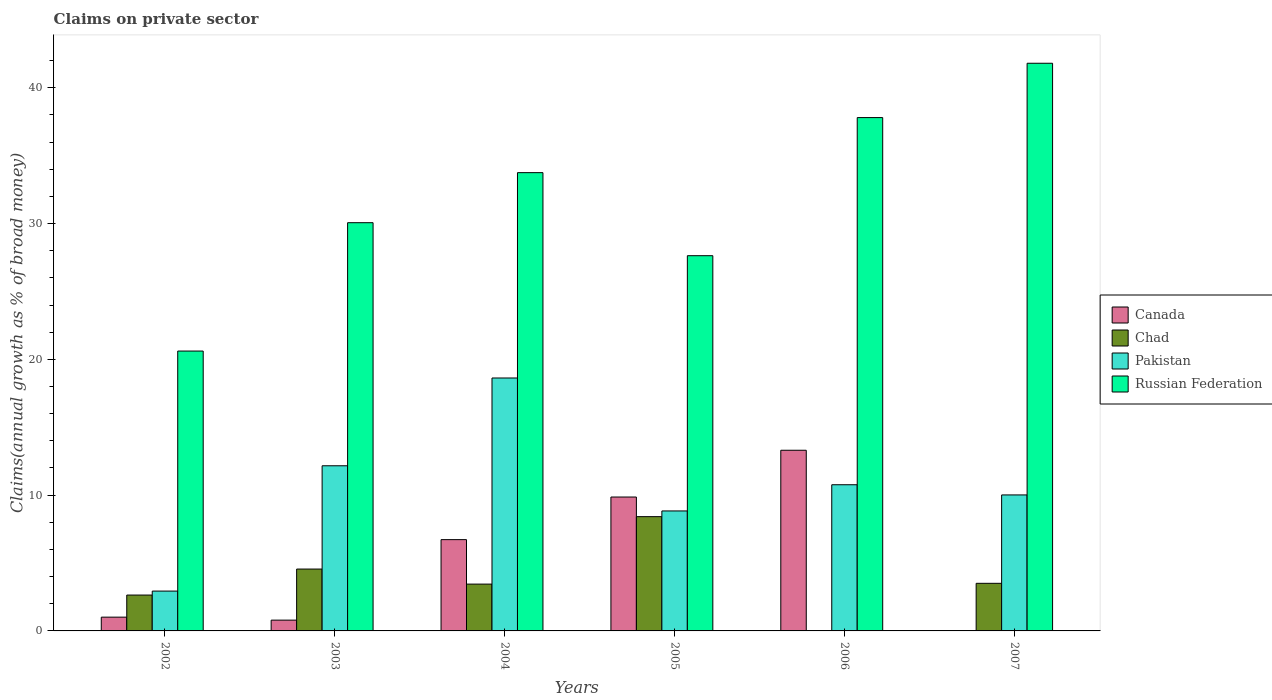Are the number of bars per tick equal to the number of legend labels?
Give a very brief answer. No. How many bars are there on the 4th tick from the right?
Ensure brevity in your answer.  4. In how many cases, is the number of bars for a given year not equal to the number of legend labels?
Your answer should be compact. 2. What is the percentage of broad money claimed on private sector in Chad in 2005?
Provide a short and direct response. 8.42. Across all years, what is the maximum percentage of broad money claimed on private sector in Pakistan?
Offer a very short reply. 18.63. What is the total percentage of broad money claimed on private sector in Canada in the graph?
Keep it short and to the point. 31.7. What is the difference between the percentage of broad money claimed on private sector in Pakistan in 2002 and that in 2007?
Give a very brief answer. -7.08. What is the difference between the percentage of broad money claimed on private sector in Canada in 2007 and the percentage of broad money claimed on private sector in Russian Federation in 2003?
Offer a very short reply. -30.06. What is the average percentage of broad money claimed on private sector in Russian Federation per year?
Provide a short and direct response. 31.94. In the year 2002, what is the difference between the percentage of broad money claimed on private sector in Canada and percentage of broad money claimed on private sector in Chad?
Ensure brevity in your answer.  -1.63. In how many years, is the percentage of broad money claimed on private sector in Pakistan greater than 6 %?
Offer a terse response. 5. What is the ratio of the percentage of broad money claimed on private sector in Chad in 2003 to that in 2007?
Your answer should be very brief. 1.3. Is the difference between the percentage of broad money claimed on private sector in Canada in 2004 and 2005 greater than the difference between the percentage of broad money claimed on private sector in Chad in 2004 and 2005?
Your answer should be very brief. Yes. What is the difference between the highest and the second highest percentage of broad money claimed on private sector in Pakistan?
Your response must be concise. 6.46. What is the difference between the highest and the lowest percentage of broad money claimed on private sector in Russian Federation?
Keep it short and to the point. 21.19. In how many years, is the percentage of broad money claimed on private sector in Chad greater than the average percentage of broad money claimed on private sector in Chad taken over all years?
Offer a terse response. 2. Is the sum of the percentage of broad money claimed on private sector in Chad in 2003 and 2004 greater than the maximum percentage of broad money claimed on private sector in Pakistan across all years?
Offer a terse response. No. What is the difference between two consecutive major ticks on the Y-axis?
Provide a succinct answer. 10. How are the legend labels stacked?
Your response must be concise. Vertical. What is the title of the graph?
Give a very brief answer. Claims on private sector. What is the label or title of the X-axis?
Your response must be concise. Years. What is the label or title of the Y-axis?
Provide a succinct answer. Claims(annual growth as % of broad money). What is the Claims(annual growth as % of broad money) of Canada in 2002?
Offer a very short reply. 1.01. What is the Claims(annual growth as % of broad money) in Chad in 2002?
Your answer should be compact. 2.64. What is the Claims(annual growth as % of broad money) in Pakistan in 2002?
Provide a short and direct response. 2.93. What is the Claims(annual growth as % of broad money) of Russian Federation in 2002?
Keep it short and to the point. 20.61. What is the Claims(annual growth as % of broad money) in Canada in 2003?
Provide a short and direct response. 0.79. What is the Claims(annual growth as % of broad money) in Chad in 2003?
Your response must be concise. 4.56. What is the Claims(annual growth as % of broad money) in Pakistan in 2003?
Your answer should be compact. 12.16. What is the Claims(annual growth as % of broad money) of Russian Federation in 2003?
Keep it short and to the point. 30.06. What is the Claims(annual growth as % of broad money) of Canada in 2004?
Ensure brevity in your answer.  6.72. What is the Claims(annual growth as % of broad money) of Chad in 2004?
Offer a very short reply. 3.45. What is the Claims(annual growth as % of broad money) in Pakistan in 2004?
Make the answer very short. 18.63. What is the Claims(annual growth as % of broad money) in Russian Federation in 2004?
Your response must be concise. 33.75. What is the Claims(annual growth as % of broad money) of Canada in 2005?
Your answer should be very brief. 9.86. What is the Claims(annual growth as % of broad money) of Chad in 2005?
Keep it short and to the point. 8.42. What is the Claims(annual growth as % of broad money) in Pakistan in 2005?
Give a very brief answer. 8.84. What is the Claims(annual growth as % of broad money) in Russian Federation in 2005?
Give a very brief answer. 27.63. What is the Claims(annual growth as % of broad money) in Canada in 2006?
Ensure brevity in your answer.  13.31. What is the Claims(annual growth as % of broad money) of Pakistan in 2006?
Provide a short and direct response. 10.76. What is the Claims(annual growth as % of broad money) of Russian Federation in 2006?
Offer a terse response. 37.8. What is the Claims(annual growth as % of broad money) of Canada in 2007?
Your answer should be compact. 0. What is the Claims(annual growth as % of broad money) in Chad in 2007?
Your response must be concise. 3.51. What is the Claims(annual growth as % of broad money) in Pakistan in 2007?
Offer a terse response. 10.01. What is the Claims(annual growth as % of broad money) in Russian Federation in 2007?
Offer a terse response. 41.8. Across all years, what is the maximum Claims(annual growth as % of broad money) in Canada?
Your answer should be very brief. 13.31. Across all years, what is the maximum Claims(annual growth as % of broad money) in Chad?
Your answer should be compact. 8.42. Across all years, what is the maximum Claims(annual growth as % of broad money) of Pakistan?
Make the answer very short. 18.63. Across all years, what is the maximum Claims(annual growth as % of broad money) in Russian Federation?
Ensure brevity in your answer.  41.8. Across all years, what is the minimum Claims(annual growth as % of broad money) of Chad?
Provide a succinct answer. 0. Across all years, what is the minimum Claims(annual growth as % of broad money) of Pakistan?
Your answer should be very brief. 2.93. Across all years, what is the minimum Claims(annual growth as % of broad money) in Russian Federation?
Give a very brief answer. 20.61. What is the total Claims(annual growth as % of broad money) in Canada in the graph?
Make the answer very short. 31.7. What is the total Claims(annual growth as % of broad money) of Chad in the graph?
Offer a terse response. 22.57. What is the total Claims(annual growth as % of broad money) of Pakistan in the graph?
Provide a short and direct response. 63.34. What is the total Claims(annual growth as % of broad money) in Russian Federation in the graph?
Provide a short and direct response. 191.66. What is the difference between the Claims(annual growth as % of broad money) of Canada in 2002 and that in 2003?
Ensure brevity in your answer.  0.22. What is the difference between the Claims(annual growth as % of broad money) of Chad in 2002 and that in 2003?
Your answer should be very brief. -1.91. What is the difference between the Claims(annual growth as % of broad money) of Pakistan in 2002 and that in 2003?
Keep it short and to the point. -9.23. What is the difference between the Claims(annual growth as % of broad money) in Russian Federation in 2002 and that in 2003?
Your answer should be very brief. -9.45. What is the difference between the Claims(annual growth as % of broad money) in Canada in 2002 and that in 2004?
Offer a very short reply. -5.71. What is the difference between the Claims(annual growth as % of broad money) in Chad in 2002 and that in 2004?
Your response must be concise. -0.81. What is the difference between the Claims(annual growth as % of broad money) of Pakistan in 2002 and that in 2004?
Your answer should be compact. -15.69. What is the difference between the Claims(annual growth as % of broad money) of Russian Federation in 2002 and that in 2004?
Offer a terse response. -13.14. What is the difference between the Claims(annual growth as % of broad money) in Canada in 2002 and that in 2005?
Keep it short and to the point. -8.85. What is the difference between the Claims(annual growth as % of broad money) of Chad in 2002 and that in 2005?
Ensure brevity in your answer.  -5.77. What is the difference between the Claims(annual growth as % of broad money) of Pakistan in 2002 and that in 2005?
Your answer should be very brief. -5.9. What is the difference between the Claims(annual growth as % of broad money) in Russian Federation in 2002 and that in 2005?
Provide a succinct answer. -7.02. What is the difference between the Claims(annual growth as % of broad money) in Canada in 2002 and that in 2006?
Keep it short and to the point. -12.29. What is the difference between the Claims(annual growth as % of broad money) of Pakistan in 2002 and that in 2006?
Your response must be concise. -7.83. What is the difference between the Claims(annual growth as % of broad money) of Russian Federation in 2002 and that in 2006?
Provide a short and direct response. -17.19. What is the difference between the Claims(annual growth as % of broad money) of Chad in 2002 and that in 2007?
Your answer should be compact. -0.86. What is the difference between the Claims(annual growth as % of broad money) in Pakistan in 2002 and that in 2007?
Offer a terse response. -7.08. What is the difference between the Claims(annual growth as % of broad money) of Russian Federation in 2002 and that in 2007?
Offer a very short reply. -21.19. What is the difference between the Claims(annual growth as % of broad money) in Canada in 2003 and that in 2004?
Provide a succinct answer. -5.93. What is the difference between the Claims(annual growth as % of broad money) of Chad in 2003 and that in 2004?
Ensure brevity in your answer.  1.11. What is the difference between the Claims(annual growth as % of broad money) of Pakistan in 2003 and that in 2004?
Your answer should be compact. -6.46. What is the difference between the Claims(annual growth as % of broad money) in Russian Federation in 2003 and that in 2004?
Give a very brief answer. -3.69. What is the difference between the Claims(annual growth as % of broad money) of Canada in 2003 and that in 2005?
Give a very brief answer. -9.07. What is the difference between the Claims(annual growth as % of broad money) of Chad in 2003 and that in 2005?
Make the answer very short. -3.86. What is the difference between the Claims(annual growth as % of broad money) in Pakistan in 2003 and that in 2005?
Make the answer very short. 3.33. What is the difference between the Claims(annual growth as % of broad money) of Russian Federation in 2003 and that in 2005?
Make the answer very short. 2.43. What is the difference between the Claims(annual growth as % of broad money) in Canada in 2003 and that in 2006?
Your answer should be compact. -12.51. What is the difference between the Claims(annual growth as % of broad money) of Pakistan in 2003 and that in 2006?
Your answer should be compact. 1.4. What is the difference between the Claims(annual growth as % of broad money) in Russian Federation in 2003 and that in 2006?
Provide a short and direct response. -7.74. What is the difference between the Claims(annual growth as % of broad money) of Chad in 2003 and that in 2007?
Keep it short and to the point. 1.05. What is the difference between the Claims(annual growth as % of broad money) of Pakistan in 2003 and that in 2007?
Offer a very short reply. 2.15. What is the difference between the Claims(annual growth as % of broad money) of Russian Federation in 2003 and that in 2007?
Ensure brevity in your answer.  -11.74. What is the difference between the Claims(annual growth as % of broad money) of Canada in 2004 and that in 2005?
Offer a very short reply. -3.14. What is the difference between the Claims(annual growth as % of broad money) of Chad in 2004 and that in 2005?
Your response must be concise. -4.97. What is the difference between the Claims(annual growth as % of broad money) in Pakistan in 2004 and that in 2005?
Make the answer very short. 9.79. What is the difference between the Claims(annual growth as % of broad money) in Russian Federation in 2004 and that in 2005?
Offer a terse response. 6.12. What is the difference between the Claims(annual growth as % of broad money) in Canada in 2004 and that in 2006?
Give a very brief answer. -6.58. What is the difference between the Claims(annual growth as % of broad money) in Pakistan in 2004 and that in 2006?
Make the answer very short. 7.86. What is the difference between the Claims(annual growth as % of broad money) in Russian Federation in 2004 and that in 2006?
Offer a very short reply. -4.06. What is the difference between the Claims(annual growth as % of broad money) in Chad in 2004 and that in 2007?
Give a very brief answer. -0.06. What is the difference between the Claims(annual growth as % of broad money) of Pakistan in 2004 and that in 2007?
Ensure brevity in your answer.  8.61. What is the difference between the Claims(annual growth as % of broad money) in Russian Federation in 2004 and that in 2007?
Provide a short and direct response. -8.06. What is the difference between the Claims(annual growth as % of broad money) of Canada in 2005 and that in 2006?
Ensure brevity in your answer.  -3.44. What is the difference between the Claims(annual growth as % of broad money) in Pakistan in 2005 and that in 2006?
Your answer should be very brief. -1.93. What is the difference between the Claims(annual growth as % of broad money) of Russian Federation in 2005 and that in 2006?
Give a very brief answer. -10.17. What is the difference between the Claims(annual growth as % of broad money) in Chad in 2005 and that in 2007?
Give a very brief answer. 4.91. What is the difference between the Claims(annual growth as % of broad money) of Pakistan in 2005 and that in 2007?
Ensure brevity in your answer.  -1.18. What is the difference between the Claims(annual growth as % of broad money) in Russian Federation in 2005 and that in 2007?
Ensure brevity in your answer.  -14.17. What is the difference between the Claims(annual growth as % of broad money) of Pakistan in 2006 and that in 2007?
Provide a short and direct response. 0.75. What is the difference between the Claims(annual growth as % of broad money) in Russian Federation in 2006 and that in 2007?
Ensure brevity in your answer.  -4. What is the difference between the Claims(annual growth as % of broad money) in Canada in 2002 and the Claims(annual growth as % of broad money) in Chad in 2003?
Keep it short and to the point. -3.54. What is the difference between the Claims(annual growth as % of broad money) in Canada in 2002 and the Claims(annual growth as % of broad money) in Pakistan in 2003?
Your response must be concise. -11.15. What is the difference between the Claims(annual growth as % of broad money) of Canada in 2002 and the Claims(annual growth as % of broad money) of Russian Federation in 2003?
Your response must be concise. -29.05. What is the difference between the Claims(annual growth as % of broad money) of Chad in 2002 and the Claims(annual growth as % of broad money) of Pakistan in 2003?
Ensure brevity in your answer.  -9.52. What is the difference between the Claims(annual growth as % of broad money) in Chad in 2002 and the Claims(annual growth as % of broad money) in Russian Federation in 2003?
Make the answer very short. -27.42. What is the difference between the Claims(annual growth as % of broad money) in Pakistan in 2002 and the Claims(annual growth as % of broad money) in Russian Federation in 2003?
Your response must be concise. -27.13. What is the difference between the Claims(annual growth as % of broad money) of Canada in 2002 and the Claims(annual growth as % of broad money) of Chad in 2004?
Your answer should be compact. -2.43. What is the difference between the Claims(annual growth as % of broad money) of Canada in 2002 and the Claims(annual growth as % of broad money) of Pakistan in 2004?
Provide a short and direct response. -17.61. What is the difference between the Claims(annual growth as % of broad money) of Canada in 2002 and the Claims(annual growth as % of broad money) of Russian Federation in 2004?
Provide a succinct answer. -32.73. What is the difference between the Claims(annual growth as % of broad money) in Chad in 2002 and the Claims(annual growth as % of broad money) in Pakistan in 2004?
Make the answer very short. -15.98. What is the difference between the Claims(annual growth as % of broad money) of Chad in 2002 and the Claims(annual growth as % of broad money) of Russian Federation in 2004?
Give a very brief answer. -31.11. What is the difference between the Claims(annual growth as % of broad money) of Pakistan in 2002 and the Claims(annual growth as % of broad money) of Russian Federation in 2004?
Provide a succinct answer. -30.81. What is the difference between the Claims(annual growth as % of broad money) in Canada in 2002 and the Claims(annual growth as % of broad money) in Chad in 2005?
Provide a short and direct response. -7.4. What is the difference between the Claims(annual growth as % of broad money) of Canada in 2002 and the Claims(annual growth as % of broad money) of Pakistan in 2005?
Your answer should be very brief. -7.82. What is the difference between the Claims(annual growth as % of broad money) in Canada in 2002 and the Claims(annual growth as % of broad money) in Russian Federation in 2005?
Ensure brevity in your answer.  -26.62. What is the difference between the Claims(annual growth as % of broad money) of Chad in 2002 and the Claims(annual growth as % of broad money) of Pakistan in 2005?
Make the answer very short. -6.19. What is the difference between the Claims(annual growth as % of broad money) of Chad in 2002 and the Claims(annual growth as % of broad money) of Russian Federation in 2005?
Your response must be concise. -24.99. What is the difference between the Claims(annual growth as % of broad money) of Pakistan in 2002 and the Claims(annual growth as % of broad money) of Russian Federation in 2005?
Keep it short and to the point. -24.7. What is the difference between the Claims(annual growth as % of broad money) of Canada in 2002 and the Claims(annual growth as % of broad money) of Pakistan in 2006?
Provide a short and direct response. -9.75. What is the difference between the Claims(annual growth as % of broad money) in Canada in 2002 and the Claims(annual growth as % of broad money) in Russian Federation in 2006?
Provide a short and direct response. -36.79. What is the difference between the Claims(annual growth as % of broad money) of Chad in 2002 and the Claims(annual growth as % of broad money) of Pakistan in 2006?
Your answer should be very brief. -8.12. What is the difference between the Claims(annual growth as % of broad money) of Chad in 2002 and the Claims(annual growth as % of broad money) of Russian Federation in 2006?
Your answer should be compact. -35.16. What is the difference between the Claims(annual growth as % of broad money) of Pakistan in 2002 and the Claims(annual growth as % of broad money) of Russian Federation in 2006?
Keep it short and to the point. -34.87. What is the difference between the Claims(annual growth as % of broad money) in Canada in 2002 and the Claims(annual growth as % of broad money) in Chad in 2007?
Provide a succinct answer. -2.49. What is the difference between the Claims(annual growth as % of broad money) of Canada in 2002 and the Claims(annual growth as % of broad money) of Pakistan in 2007?
Your answer should be very brief. -9. What is the difference between the Claims(annual growth as % of broad money) of Canada in 2002 and the Claims(annual growth as % of broad money) of Russian Federation in 2007?
Provide a short and direct response. -40.79. What is the difference between the Claims(annual growth as % of broad money) in Chad in 2002 and the Claims(annual growth as % of broad money) in Pakistan in 2007?
Ensure brevity in your answer.  -7.37. What is the difference between the Claims(annual growth as % of broad money) in Chad in 2002 and the Claims(annual growth as % of broad money) in Russian Federation in 2007?
Keep it short and to the point. -39.16. What is the difference between the Claims(annual growth as % of broad money) of Pakistan in 2002 and the Claims(annual growth as % of broad money) of Russian Federation in 2007?
Give a very brief answer. -38.87. What is the difference between the Claims(annual growth as % of broad money) in Canada in 2003 and the Claims(annual growth as % of broad money) in Chad in 2004?
Ensure brevity in your answer.  -2.65. What is the difference between the Claims(annual growth as % of broad money) of Canada in 2003 and the Claims(annual growth as % of broad money) of Pakistan in 2004?
Offer a very short reply. -17.83. What is the difference between the Claims(annual growth as % of broad money) of Canada in 2003 and the Claims(annual growth as % of broad money) of Russian Federation in 2004?
Make the answer very short. -32.95. What is the difference between the Claims(annual growth as % of broad money) of Chad in 2003 and the Claims(annual growth as % of broad money) of Pakistan in 2004?
Give a very brief answer. -14.07. What is the difference between the Claims(annual growth as % of broad money) in Chad in 2003 and the Claims(annual growth as % of broad money) in Russian Federation in 2004?
Keep it short and to the point. -29.19. What is the difference between the Claims(annual growth as % of broad money) of Pakistan in 2003 and the Claims(annual growth as % of broad money) of Russian Federation in 2004?
Provide a succinct answer. -21.59. What is the difference between the Claims(annual growth as % of broad money) in Canada in 2003 and the Claims(annual growth as % of broad money) in Chad in 2005?
Provide a succinct answer. -7.62. What is the difference between the Claims(annual growth as % of broad money) in Canada in 2003 and the Claims(annual growth as % of broad money) in Pakistan in 2005?
Keep it short and to the point. -8.04. What is the difference between the Claims(annual growth as % of broad money) in Canada in 2003 and the Claims(annual growth as % of broad money) in Russian Federation in 2005?
Your answer should be compact. -26.84. What is the difference between the Claims(annual growth as % of broad money) of Chad in 2003 and the Claims(annual growth as % of broad money) of Pakistan in 2005?
Offer a very short reply. -4.28. What is the difference between the Claims(annual growth as % of broad money) of Chad in 2003 and the Claims(annual growth as % of broad money) of Russian Federation in 2005?
Your answer should be very brief. -23.08. What is the difference between the Claims(annual growth as % of broad money) of Pakistan in 2003 and the Claims(annual growth as % of broad money) of Russian Federation in 2005?
Keep it short and to the point. -15.47. What is the difference between the Claims(annual growth as % of broad money) of Canada in 2003 and the Claims(annual growth as % of broad money) of Pakistan in 2006?
Offer a terse response. -9.97. What is the difference between the Claims(annual growth as % of broad money) of Canada in 2003 and the Claims(annual growth as % of broad money) of Russian Federation in 2006?
Your answer should be very brief. -37.01. What is the difference between the Claims(annual growth as % of broad money) in Chad in 2003 and the Claims(annual growth as % of broad money) in Pakistan in 2006?
Keep it short and to the point. -6.21. What is the difference between the Claims(annual growth as % of broad money) of Chad in 2003 and the Claims(annual growth as % of broad money) of Russian Federation in 2006?
Ensure brevity in your answer.  -33.25. What is the difference between the Claims(annual growth as % of broad money) in Pakistan in 2003 and the Claims(annual growth as % of broad money) in Russian Federation in 2006?
Keep it short and to the point. -25.64. What is the difference between the Claims(annual growth as % of broad money) of Canada in 2003 and the Claims(annual growth as % of broad money) of Chad in 2007?
Your answer should be very brief. -2.71. What is the difference between the Claims(annual growth as % of broad money) in Canada in 2003 and the Claims(annual growth as % of broad money) in Pakistan in 2007?
Provide a succinct answer. -9.22. What is the difference between the Claims(annual growth as % of broad money) of Canada in 2003 and the Claims(annual growth as % of broad money) of Russian Federation in 2007?
Your answer should be very brief. -41.01. What is the difference between the Claims(annual growth as % of broad money) of Chad in 2003 and the Claims(annual growth as % of broad money) of Pakistan in 2007?
Your answer should be very brief. -5.46. What is the difference between the Claims(annual growth as % of broad money) in Chad in 2003 and the Claims(annual growth as % of broad money) in Russian Federation in 2007?
Ensure brevity in your answer.  -37.25. What is the difference between the Claims(annual growth as % of broad money) of Pakistan in 2003 and the Claims(annual growth as % of broad money) of Russian Federation in 2007?
Ensure brevity in your answer.  -29.64. What is the difference between the Claims(annual growth as % of broad money) in Canada in 2004 and the Claims(annual growth as % of broad money) in Chad in 2005?
Offer a terse response. -1.69. What is the difference between the Claims(annual growth as % of broad money) in Canada in 2004 and the Claims(annual growth as % of broad money) in Pakistan in 2005?
Your answer should be very brief. -2.11. What is the difference between the Claims(annual growth as % of broad money) in Canada in 2004 and the Claims(annual growth as % of broad money) in Russian Federation in 2005?
Keep it short and to the point. -20.91. What is the difference between the Claims(annual growth as % of broad money) in Chad in 2004 and the Claims(annual growth as % of broad money) in Pakistan in 2005?
Your response must be concise. -5.39. What is the difference between the Claims(annual growth as % of broad money) of Chad in 2004 and the Claims(annual growth as % of broad money) of Russian Federation in 2005?
Your answer should be compact. -24.18. What is the difference between the Claims(annual growth as % of broad money) in Pakistan in 2004 and the Claims(annual growth as % of broad money) in Russian Federation in 2005?
Provide a short and direct response. -9.01. What is the difference between the Claims(annual growth as % of broad money) of Canada in 2004 and the Claims(annual growth as % of broad money) of Pakistan in 2006?
Provide a short and direct response. -4.04. What is the difference between the Claims(annual growth as % of broad money) of Canada in 2004 and the Claims(annual growth as % of broad money) of Russian Federation in 2006?
Give a very brief answer. -31.08. What is the difference between the Claims(annual growth as % of broad money) in Chad in 2004 and the Claims(annual growth as % of broad money) in Pakistan in 2006?
Offer a very short reply. -7.32. What is the difference between the Claims(annual growth as % of broad money) of Chad in 2004 and the Claims(annual growth as % of broad money) of Russian Federation in 2006?
Provide a succinct answer. -34.36. What is the difference between the Claims(annual growth as % of broad money) in Pakistan in 2004 and the Claims(annual growth as % of broad money) in Russian Federation in 2006?
Your answer should be compact. -19.18. What is the difference between the Claims(annual growth as % of broad money) of Canada in 2004 and the Claims(annual growth as % of broad money) of Chad in 2007?
Provide a succinct answer. 3.22. What is the difference between the Claims(annual growth as % of broad money) in Canada in 2004 and the Claims(annual growth as % of broad money) in Pakistan in 2007?
Make the answer very short. -3.29. What is the difference between the Claims(annual growth as % of broad money) in Canada in 2004 and the Claims(annual growth as % of broad money) in Russian Federation in 2007?
Your response must be concise. -35.08. What is the difference between the Claims(annual growth as % of broad money) of Chad in 2004 and the Claims(annual growth as % of broad money) of Pakistan in 2007?
Keep it short and to the point. -6.57. What is the difference between the Claims(annual growth as % of broad money) of Chad in 2004 and the Claims(annual growth as % of broad money) of Russian Federation in 2007?
Make the answer very short. -38.36. What is the difference between the Claims(annual growth as % of broad money) of Pakistan in 2004 and the Claims(annual growth as % of broad money) of Russian Federation in 2007?
Offer a very short reply. -23.18. What is the difference between the Claims(annual growth as % of broad money) in Canada in 2005 and the Claims(annual growth as % of broad money) in Pakistan in 2006?
Provide a succinct answer. -0.9. What is the difference between the Claims(annual growth as % of broad money) of Canada in 2005 and the Claims(annual growth as % of broad money) of Russian Federation in 2006?
Your answer should be very brief. -27.94. What is the difference between the Claims(annual growth as % of broad money) in Chad in 2005 and the Claims(annual growth as % of broad money) in Pakistan in 2006?
Keep it short and to the point. -2.35. What is the difference between the Claims(annual growth as % of broad money) of Chad in 2005 and the Claims(annual growth as % of broad money) of Russian Federation in 2006?
Keep it short and to the point. -29.39. What is the difference between the Claims(annual growth as % of broad money) in Pakistan in 2005 and the Claims(annual growth as % of broad money) in Russian Federation in 2006?
Your answer should be very brief. -28.97. What is the difference between the Claims(annual growth as % of broad money) of Canada in 2005 and the Claims(annual growth as % of broad money) of Chad in 2007?
Your answer should be compact. 6.35. What is the difference between the Claims(annual growth as % of broad money) of Canada in 2005 and the Claims(annual growth as % of broad money) of Pakistan in 2007?
Keep it short and to the point. -0.15. What is the difference between the Claims(annual growth as % of broad money) in Canada in 2005 and the Claims(annual growth as % of broad money) in Russian Federation in 2007?
Your answer should be very brief. -31.94. What is the difference between the Claims(annual growth as % of broad money) in Chad in 2005 and the Claims(annual growth as % of broad money) in Pakistan in 2007?
Keep it short and to the point. -1.6. What is the difference between the Claims(annual growth as % of broad money) of Chad in 2005 and the Claims(annual growth as % of broad money) of Russian Federation in 2007?
Offer a terse response. -33.39. What is the difference between the Claims(annual growth as % of broad money) of Pakistan in 2005 and the Claims(annual growth as % of broad money) of Russian Federation in 2007?
Ensure brevity in your answer.  -32.97. What is the difference between the Claims(annual growth as % of broad money) in Canada in 2006 and the Claims(annual growth as % of broad money) in Chad in 2007?
Your answer should be very brief. 9.8. What is the difference between the Claims(annual growth as % of broad money) of Canada in 2006 and the Claims(annual growth as % of broad money) of Pakistan in 2007?
Your response must be concise. 3.29. What is the difference between the Claims(annual growth as % of broad money) in Canada in 2006 and the Claims(annual growth as % of broad money) in Russian Federation in 2007?
Your response must be concise. -28.5. What is the difference between the Claims(annual growth as % of broad money) of Pakistan in 2006 and the Claims(annual growth as % of broad money) of Russian Federation in 2007?
Offer a very short reply. -31.04. What is the average Claims(annual growth as % of broad money) of Canada per year?
Your answer should be compact. 5.28. What is the average Claims(annual growth as % of broad money) in Chad per year?
Your answer should be very brief. 3.76. What is the average Claims(annual growth as % of broad money) of Pakistan per year?
Offer a terse response. 10.56. What is the average Claims(annual growth as % of broad money) in Russian Federation per year?
Ensure brevity in your answer.  31.94. In the year 2002, what is the difference between the Claims(annual growth as % of broad money) in Canada and Claims(annual growth as % of broad money) in Chad?
Provide a succinct answer. -1.63. In the year 2002, what is the difference between the Claims(annual growth as % of broad money) of Canada and Claims(annual growth as % of broad money) of Pakistan?
Your answer should be very brief. -1.92. In the year 2002, what is the difference between the Claims(annual growth as % of broad money) of Canada and Claims(annual growth as % of broad money) of Russian Federation?
Your answer should be compact. -19.6. In the year 2002, what is the difference between the Claims(annual growth as % of broad money) of Chad and Claims(annual growth as % of broad money) of Pakistan?
Give a very brief answer. -0.29. In the year 2002, what is the difference between the Claims(annual growth as % of broad money) of Chad and Claims(annual growth as % of broad money) of Russian Federation?
Your response must be concise. -17.97. In the year 2002, what is the difference between the Claims(annual growth as % of broad money) in Pakistan and Claims(annual growth as % of broad money) in Russian Federation?
Your answer should be compact. -17.68. In the year 2003, what is the difference between the Claims(annual growth as % of broad money) in Canada and Claims(annual growth as % of broad money) in Chad?
Make the answer very short. -3.76. In the year 2003, what is the difference between the Claims(annual growth as % of broad money) in Canada and Claims(annual growth as % of broad money) in Pakistan?
Offer a terse response. -11.37. In the year 2003, what is the difference between the Claims(annual growth as % of broad money) of Canada and Claims(annual growth as % of broad money) of Russian Federation?
Make the answer very short. -29.27. In the year 2003, what is the difference between the Claims(annual growth as % of broad money) in Chad and Claims(annual growth as % of broad money) in Pakistan?
Offer a terse response. -7.61. In the year 2003, what is the difference between the Claims(annual growth as % of broad money) of Chad and Claims(annual growth as % of broad money) of Russian Federation?
Keep it short and to the point. -25.51. In the year 2003, what is the difference between the Claims(annual growth as % of broad money) in Pakistan and Claims(annual growth as % of broad money) in Russian Federation?
Provide a succinct answer. -17.9. In the year 2004, what is the difference between the Claims(annual growth as % of broad money) in Canada and Claims(annual growth as % of broad money) in Chad?
Provide a succinct answer. 3.27. In the year 2004, what is the difference between the Claims(annual growth as % of broad money) of Canada and Claims(annual growth as % of broad money) of Pakistan?
Give a very brief answer. -11.9. In the year 2004, what is the difference between the Claims(annual growth as % of broad money) of Canada and Claims(annual growth as % of broad money) of Russian Federation?
Give a very brief answer. -27.03. In the year 2004, what is the difference between the Claims(annual growth as % of broad money) of Chad and Claims(annual growth as % of broad money) of Pakistan?
Your answer should be compact. -15.18. In the year 2004, what is the difference between the Claims(annual growth as % of broad money) in Chad and Claims(annual growth as % of broad money) in Russian Federation?
Keep it short and to the point. -30.3. In the year 2004, what is the difference between the Claims(annual growth as % of broad money) in Pakistan and Claims(annual growth as % of broad money) in Russian Federation?
Your response must be concise. -15.12. In the year 2005, what is the difference between the Claims(annual growth as % of broad money) of Canada and Claims(annual growth as % of broad money) of Chad?
Offer a terse response. 1.44. In the year 2005, what is the difference between the Claims(annual growth as % of broad money) in Canada and Claims(annual growth as % of broad money) in Pakistan?
Make the answer very short. 1.02. In the year 2005, what is the difference between the Claims(annual growth as % of broad money) in Canada and Claims(annual growth as % of broad money) in Russian Federation?
Provide a short and direct response. -17.77. In the year 2005, what is the difference between the Claims(annual growth as % of broad money) of Chad and Claims(annual growth as % of broad money) of Pakistan?
Your answer should be compact. -0.42. In the year 2005, what is the difference between the Claims(annual growth as % of broad money) in Chad and Claims(annual growth as % of broad money) in Russian Federation?
Your answer should be compact. -19.22. In the year 2005, what is the difference between the Claims(annual growth as % of broad money) of Pakistan and Claims(annual growth as % of broad money) of Russian Federation?
Your answer should be very brief. -18.8. In the year 2006, what is the difference between the Claims(annual growth as % of broad money) of Canada and Claims(annual growth as % of broad money) of Pakistan?
Ensure brevity in your answer.  2.54. In the year 2006, what is the difference between the Claims(annual growth as % of broad money) of Canada and Claims(annual growth as % of broad money) of Russian Federation?
Your answer should be compact. -24.5. In the year 2006, what is the difference between the Claims(annual growth as % of broad money) in Pakistan and Claims(annual growth as % of broad money) in Russian Federation?
Provide a short and direct response. -27.04. In the year 2007, what is the difference between the Claims(annual growth as % of broad money) in Chad and Claims(annual growth as % of broad money) in Pakistan?
Keep it short and to the point. -6.51. In the year 2007, what is the difference between the Claims(annual growth as % of broad money) in Chad and Claims(annual growth as % of broad money) in Russian Federation?
Your answer should be very brief. -38.3. In the year 2007, what is the difference between the Claims(annual growth as % of broad money) in Pakistan and Claims(annual growth as % of broad money) in Russian Federation?
Your response must be concise. -31.79. What is the ratio of the Claims(annual growth as % of broad money) of Canada in 2002 to that in 2003?
Provide a short and direct response. 1.28. What is the ratio of the Claims(annual growth as % of broad money) of Chad in 2002 to that in 2003?
Your answer should be compact. 0.58. What is the ratio of the Claims(annual growth as % of broad money) in Pakistan in 2002 to that in 2003?
Your response must be concise. 0.24. What is the ratio of the Claims(annual growth as % of broad money) in Russian Federation in 2002 to that in 2003?
Your response must be concise. 0.69. What is the ratio of the Claims(annual growth as % of broad money) in Canada in 2002 to that in 2004?
Make the answer very short. 0.15. What is the ratio of the Claims(annual growth as % of broad money) in Chad in 2002 to that in 2004?
Make the answer very short. 0.77. What is the ratio of the Claims(annual growth as % of broad money) of Pakistan in 2002 to that in 2004?
Your response must be concise. 0.16. What is the ratio of the Claims(annual growth as % of broad money) in Russian Federation in 2002 to that in 2004?
Your answer should be compact. 0.61. What is the ratio of the Claims(annual growth as % of broad money) of Canada in 2002 to that in 2005?
Provide a succinct answer. 0.1. What is the ratio of the Claims(annual growth as % of broad money) in Chad in 2002 to that in 2005?
Your response must be concise. 0.31. What is the ratio of the Claims(annual growth as % of broad money) of Pakistan in 2002 to that in 2005?
Your response must be concise. 0.33. What is the ratio of the Claims(annual growth as % of broad money) of Russian Federation in 2002 to that in 2005?
Your response must be concise. 0.75. What is the ratio of the Claims(annual growth as % of broad money) of Canada in 2002 to that in 2006?
Provide a short and direct response. 0.08. What is the ratio of the Claims(annual growth as % of broad money) in Pakistan in 2002 to that in 2006?
Ensure brevity in your answer.  0.27. What is the ratio of the Claims(annual growth as % of broad money) in Russian Federation in 2002 to that in 2006?
Make the answer very short. 0.55. What is the ratio of the Claims(annual growth as % of broad money) in Chad in 2002 to that in 2007?
Offer a very short reply. 0.75. What is the ratio of the Claims(annual growth as % of broad money) of Pakistan in 2002 to that in 2007?
Keep it short and to the point. 0.29. What is the ratio of the Claims(annual growth as % of broad money) of Russian Federation in 2002 to that in 2007?
Provide a short and direct response. 0.49. What is the ratio of the Claims(annual growth as % of broad money) in Canada in 2003 to that in 2004?
Provide a short and direct response. 0.12. What is the ratio of the Claims(annual growth as % of broad money) in Chad in 2003 to that in 2004?
Give a very brief answer. 1.32. What is the ratio of the Claims(annual growth as % of broad money) of Pakistan in 2003 to that in 2004?
Provide a short and direct response. 0.65. What is the ratio of the Claims(annual growth as % of broad money) of Russian Federation in 2003 to that in 2004?
Give a very brief answer. 0.89. What is the ratio of the Claims(annual growth as % of broad money) of Canada in 2003 to that in 2005?
Make the answer very short. 0.08. What is the ratio of the Claims(annual growth as % of broad money) of Chad in 2003 to that in 2005?
Your response must be concise. 0.54. What is the ratio of the Claims(annual growth as % of broad money) in Pakistan in 2003 to that in 2005?
Your response must be concise. 1.38. What is the ratio of the Claims(annual growth as % of broad money) in Russian Federation in 2003 to that in 2005?
Give a very brief answer. 1.09. What is the ratio of the Claims(annual growth as % of broad money) in Canada in 2003 to that in 2006?
Your answer should be very brief. 0.06. What is the ratio of the Claims(annual growth as % of broad money) in Pakistan in 2003 to that in 2006?
Keep it short and to the point. 1.13. What is the ratio of the Claims(annual growth as % of broad money) in Russian Federation in 2003 to that in 2006?
Keep it short and to the point. 0.8. What is the ratio of the Claims(annual growth as % of broad money) of Chad in 2003 to that in 2007?
Give a very brief answer. 1.3. What is the ratio of the Claims(annual growth as % of broad money) of Pakistan in 2003 to that in 2007?
Provide a succinct answer. 1.21. What is the ratio of the Claims(annual growth as % of broad money) of Russian Federation in 2003 to that in 2007?
Provide a succinct answer. 0.72. What is the ratio of the Claims(annual growth as % of broad money) in Canada in 2004 to that in 2005?
Offer a very short reply. 0.68. What is the ratio of the Claims(annual growth as % of broad money) in Chad in 2004 to that in 2005?
Your answer should be very brief. 0.41. What is the ratio of the Claims(annual growth as % of broad money) in Pakistan in 2004 to that in 2005?
Your answer should be compact. 2.11. What is the ratio of the Claims(annual growth as % of broad money) of Russian Federation in 2004 to that in 2005?
Your response must be concise. 1.22. What is the ratio of the Claims(annual growth as % of broad money) of Canada in 2004 to that in 2006?
Ensure brevity in your answer.  0.51. What is the ratio of the Claims(annual growth as % of broad money) of Pakistan in 2004 to that in 2006?
Your answer should be compact. 1.73. What is the ratio of the Claims(annual growth as % of broad money) in Russian Federation in 2004 to that in 2006?
Provide a succinct answer. 0.89. What is the ratio of the Claims(annual growth as % of broad money) in Chad in 2004 to that in 2007?
Your answer should be compact. 0.98. What is the ratio of the Claims(annual growth as % of broad money) in Pakistan in 2004 to that in 2007?
Make the answer very short. 1.86. What is the ratio of the Claims(annual growth as % of broad money) in Russian Federation in 2004 to that in 2007?
Offer a very short reply. 0.81. What is the ratio of the Claims(annual growth as % of broad money) in Canada in 2005 to that in 2006?
Ensure brevity in your answer.  0.74. What is the ratio of the Claims(annual growth as % of broad money) of Pakistan in 2005 to that in 2006?
Make the answer very short. 0.82. What is the ratio of the Claims(annual growth as % of broad money) of Russian Federation in 2005 to that in 2006?
Keep it short and to the point. 0.73. What is the ratio of the Claims(annual growth as % of broad money) in Chad in 2005 to that in 2007?
Give a very brief answer. 2.4. What is the ratio of the Claims(annual growth as % of broad money) in Pakistan in 2005 to that in 2007?
Ensure brevity in your answer.  0.88. What is the ratio of the Claims(annual growth as % of broad money) of Russian Federation in 2005 to that in 2007?
Make the answer very short. 0.66. What is the ratio of the Claims(annual growth as % of broad money) in Pakistan in 2006 to that in 2007?
Keep it short and to the point. 1.07. What is the ratio of the Claims(annual growth as % of broad money) of Russian Federation in 2006 to that in 2007?
Your answer should be compact. 0.9. What is the difference between the highest and the second highest Claims(annual growth as % of broad money) in Canada?
Keep it short and to the point. 3.44. What is the difference between the highest and the second highest Claims(annual growth as % of broad money) of Chad?
Make the answer very short. 3.86. What is the difference between the highest and the second highest Claims(annual growth as % of broad money) in Pakistan?
Your answer should be very brief. 6.46. What is the difference between the highest and the second highest Claims(annual growth as % of broad money) of Russian Federation?
Offer a terse response. 4. What is the difference between the highest and the lowest Claims(annual growth as % of broad money) in Canada?
Provide a short and direct response. 13.3. What is the difference between the highest and the lowest Claims(annual growth as % of broad money) in Chad?
Provide a succinct answer. 8.42. What is the difference between the highest and the lowest Claims(annual growth as % of broad money) of Pakistan?
Your answer should be very brief. 15.69. What is the difference between the highest and the lowest Claims(annual growth as % of broad money) in Russian Federation?
Your answer should be very brief. 21.19. 